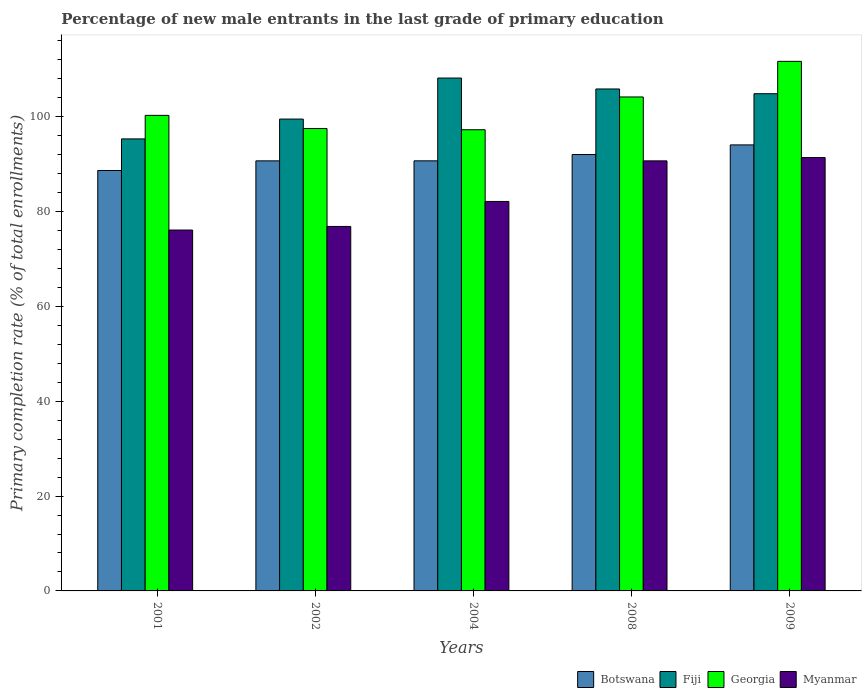How many bars are there on the 3rd tick from the left?
Your response must be concise. 4. How many bars are there on the 4th tick from the right?
Your answer should be very brief. 4. What is the label of the 3rd group of bars from the left?
Your response must be concise. 2004. In how many cases, is the number of bars for a given year not equal to the number of legend labels?
Ensure brevity in your answer.  0. What is the percentage of new male entrants in Botswana in 2008?
Offer a terse response. 92.02. Across all years, what is the maximum percentage of new male entrants in Botswana?
Provide a short and direct response. 94.05. Across all years, what is the minimum percentage of new male entrants in Fiji?
Provide a short and direct response. 95.32. What is the total percentage of new male entrants in Botswana in the graph?
Your answer should be compact. 456.12. What is the difference between the percentage of new male entrants in Myanmar in 2002 and that in 2008?
Keep it short and to the point. -13.83. What is the difference between the percentage of new male entrants in Georgia in 2008 and the percentage of new male entrants in Fiji in 2004?
Make the answer very short. -3.99. What is the average percentage of new male entrants in Botswana per year?
Offer a very short reply. 91.22. In the year 2001, what is the difference between the percentage of new male entrants in Georgia and percentage of new male entrants in Fiji?
Give a very brief answer. 4.96. What is the ratio of the percentage of new male entrants in Myanmar in 2004 to that in 2009?
Ensure brevity in your answer.  0.9. Is the difference between the percentage of new male entrants in Georgia in 2004 and 2009 greater than the difference between the percentage of new male entrants in Fiji in 2004 and 2009?
Your response must be concise. No. What is the difference between the highest and the second highest percentage of new male entrants in Fiji?
Offer a terse response. 2.3. What is the difference between the highest and the lowest percentage of new male entrants in Myanmar?
Keep it short and to the point. 15.28. What does the 2nd bar from the left in 2002 represents?
Provide a succinct answer. Fiji. What does the 1st bar from the right in 2002 represents?
Your answer should be compact. Myanmar. Is it the case that in every year, the sum of the percentage of new male entrants in Fiji and percentage of new male entrants in Myanmar is greater than the percentage of new male entrants in Georgia?
Offer a very short reply. Yes. How many bars are there?
Your response must be concise. 20. What is the difference between two consecutive major ticks on the Y-axis?
Your answer should be very brief. 20. Are the values on the major ticks of Y-axis written in scientific E-notation?
Provide a short and direct response. No. How many legend labels are there?
Ensure brevity in your answer.  4. What is the title of the graph?
Your response must be concise. Percentage of new male entrants in the last grade of primary education. What is the label or title of the X-axis?
Offer a very short reply. Years. What is the label or title of the Y-axis?
Keep it short and to the point. Primary completion rate (% of total enrollments). What is the Primary completion rate (% of total enrollments) of Botswana in 2001?
Your answer should be compact. 88.66. What is the Primary completion rate (% of total enrollments) of Fiji in 2001?
Make the answer very short. 95.32. What is the Primary completion rate (% of total enrollments) in Georgia in 2001?
Offer a terse response. 100.28. What is the Primary completion rate (% of total enrollments) of Myanmar in 2001?
Offer a very short reply. 76.1. What is the Primary completion rate (% of total enrollments) of Botswana in 2002?
Make the answer very short. 90.69. What is the Primary completion rate (% of total enrollments) in Fiji in 2002?
Provide a short and direct response. 99.5. What is the Primary completion rate (% of total enrollments) of Georgia in 2002?
Your answer should be very brief. 97.51. What is the Primary completion rate (% of total enrollments) of Myanmar in 2002?
Provide a short and direct response. 76.86. What is the Primary completion rate (% of total enrollments) in Botswana in 2004?
Offer a very short reply. 90.7. What is the Primary completion rate (% of total enrollments) in Fiji in 2004?
Your answer should be compact. 108.15. What is the Primary completion rate (% of total enrollments) in Georgia in 2004?
Provide a succinct answer. 97.25. What is the Primary completion rate (% of total enrollments) in Myanmar in 2004?
Your response must be concise. 82.13. What is the Primary completion rate (% of total enrollments) in Botswana in 2008?
Your answer should be compact. 92.02. What is the Primary completion rate (% of total enrollments) of Fiji in 2008?
Provide a succinct answer. 105.85. What is the Primary completion rate (% of total enrollments) in Georgia in 2008?
Give a very brief answer. 104.16. What is the Primary completion rate (% of total enrollments) in Myanmar in 2008?
Keep it short and to the point. 90.69. What is the Primary completion rate (% of total enrollments) in Botswana in 2009?
Keep it short and to the point. 94.05. What is the Primary completion rate (% of total enrollments) of Fiji in 2009?
Provide a short and direct response. 104.85. What is the Primary completion rate (% of total enrollments) in Georgia in 2009?
Provide a succinct answer. 111.67. What is the Primary completion rate (% of total enrollments) in Myanmar in 2009?
Make the answer very short. 91.38. Across all years, what is the maximum Primary completion rate (% of total enrollments) of Botswana?
Provide a succinct answer. 94.05. Across all years, what is the maximum Primary completion rate (% of total enrollments) in Fiji?
Give a very brief answer. 108.15. Across all years, what is the maximum Primary completion rate (% of total enrollments) of Georgia?
Your answer should be very brief. 111.67. Across all years, what is the maximum Primary completion rate (% of total enrollments) of Myanmar?
Make the answer very short. 91.38. Across all years, what is the minimum Primary completion rate (% of total enrollments) in Botswana?
Your answer should be compact. 88.66. Across all years, what is the minimum Primary completion rate (% of total enrollments) of Fiji?
Your answer should be compact. 95.32. Across all years, what is the minimum Primary completion rate (% of total enrollments) in Georgia?
Ensure brevity in your answer.  97.25. Across all years, what is the minimum Primary completion rate (% of total enrollments) of Myanmar?
Provide a succinct answer. 76.1. What is the total Primary completion rate (% of total enrollments) in Botswana in the graph?
Your answer should be compact. 456.12. What is the total Primary completion rate (% of total enrollments) of Fiji in the graph?
Provide a succinct answer. 513.68. What is the total Primary completion rate (% of total enrollments) in Georgia in the graph?
Offer a terse response. 510.88. What is the total Primary completion rate (% of total enrollments) of Myanmar in the graph?
Your answer should be compact. 417.16. What is the difference between the Primary completion rate (% of total enrollments) in Botswana in 2001 and that in 2002?
Keep it short and to the point. -2.03. What is the difference between the Primary completion rate (% of total enrollments) in Fiji in 2001 and that in 2002?
Your answer should be compact. -4.18. What is the difference between the Primary completion rate (% of total enrollments) of Georgia in 2001 and that in 2002?
Give a very brief answer. 2.77. What is the difference between the Primary completion rate (% of total enrollments) in Myanmar in 2001 and that in 2002?
Ensure brevity in your answer.  -0.76. What is the difference between the Primary completion rate (% of total enrollments) in Botswana in 2001 and that in 2004?
Give a very brief answer. -2.04. What is the difference between the Primary completion rate (% of total enrollments) in Fiji in 2001 and that in 2004?
Your answer should be very brief. -12.83. What is the difference between the Primary completion rate (% of total enrollments) in Georgia in 2001 and that in 2004?
Your answer should be compact. 3.03. What is the difference between the Primary completion rate (% of total enrollments) of Myanmar in 2001 and that in 2004?
Keep it short and to the point. -6.03. What is the difference between the Primary completion rate (% of total enrollments) of Botswana in 2001 and that in 2008?
Provide a short and direct response. -3.37. What is the difference between the Primary completion rate (% of total enrollments) of Fiji in 2001 and that in 2008?
Your response must be concise. -10.53. What is the difference between the Primary completion rate (% of total enrollments) of Georgia in 2001 and that in 2008?
Your answer should be compact. -3.88. What is the difference between the Primary completion rate (% of total enrollments) in Myanmar in 2001 and that in 2008?
Give a very brief answer. -14.58. What is the difference between the Primary completion rate (% of total enrollments) in Botswana in 2001 and that in 2009?
Your response must be concise. -5.4. What is the difference between the Primary completion rate (% of total enrollments) in Fiji in 2001 and that in 2009?
Your response must be concise. -9.53. What is the difference between the Primary completion rate (% of total enrollments) in Georgia in 2001 and that in 2009?
Offer a very short reply. -11.39. What is the difference between the Primary completion rate (% of total enrollments) of Myanmar in 2001 and that in 2009?
Give a very brief answer. -15.28. What is the difference between the Primary completion rate (% of total enrollments) of Botswana in 2002 and that in 2004?
Make the answer very short. -0.01. What is the difference between the Primary completion rate (% of total enrollments) of Fiji in 2002 and that in 2004?
Offer a very short reply. -8.65. What is the difference between the Primary completion rate (% of total enrollments) of Georgia in 2002 and that in 2004?
Make the answer very short. 0.25. What is the difference between the Primary completion rate (% of total enrollments) in Myanmar in 2002 and that in 2004?
Keep it short and to the point. -5.27. What is the difference between the Primary completion rate (% of total enrollments) of Botswana in 2002 and that in 2008?
Your answer should be very brief. -1.33. What is the difference between the Primary completion rate (% of total enrollments) of Fiji in 2002 and that in 2008?
Ensure brevity in your answer.  -6.35. What is the difference between the Primary completion rate (% of total enrollments) of Georgia in 2002 and that in 2008?
Offer a terse response. -6.66. What is the difference between the Primary completion rate (% of total enrollments) in Myanmar in 2002 and that in 2008?
Make the answer very short. -13.83. What is the difference between the Primary completion rate (% of total enrollments) in Botswana in 2002 and that in 2009?
Provide a succinct answer. -3.36. What is the difference between the Primary completion rate (% of total enrollments) in Fiji in 2002 and that in 2009?
Your answer should be compact. -5.35. What is the difference between the Primary completion rate (% of total enrollments) in Georgia in 2002 and that in 2009?
Provide a short and direct response. -14.17. What is the difference between the Primary completion rate (% of total enrollments) in Myanmar in 2002 and that in 2009?
Keep it short and to the point. -14.52. What is the difference between the Primary completion rate (% of total enrollments) of Botswana in 2004 and that in 2008?
Keep it short and to the point. -1.33. What is the difference between the Primary completion rate (% of total enrollments) in Fiji in 2004 and that in 2008?
Your response must be concise. 2.3. What is the difference between the Primary completion rate (% of total enrollments) in Georgia in 2004 and that in 2008?
Keep it short and to the point. -6.91. What is the difference between the Primary completion rate (% of total enrollments) of Myanmar in 2004 and that in 2008?
Keep it short and to the point. -8.56. What is the difference between the Primary completion rate (% of total enrollments) of Botswana in 2004 and that in 2009?
Make the answer very short. -3.36. What is the difference between the Primary completion rate (% of total enrollments) of Fiji in 2004 and that in 2009?
Make the answer very short. 3.3. What is the difference between the Primary completion rate (% of total enrollments) in Georgia in 2004 and that in 2009?
Your answer should be compact. -14.42. What is the difference between the Primary completion rate (% of total enrollments) of Myanmar in 2004 and that in 2009?
Provide a short and direct response. -9.25. What is the difference between the Primary completion rate (% of total enrollments) of Botswana in 2008 and that in 2009?
Your answer should be compact. -2.03. What is the difference between the Primary completion rate (% of total enrollments) in Georgia in 2008 and that in 2009?
Provide a succinct answer. -7.51. What is the difference between the Primary completion rate (% of total enrollments) of Myanmar in 2008 and that in 2009?
Provide a short and direct response. -0.7. What is the difference between the Primary completion rate (% of total enrollments) of Botswana in 2001 and the Primary completion rate (% of total enrollments) of Fiji in 2002?
Offer a very short reply. -10.84. What is the difference between the Primary completion rate (% of total enrollments) of Botswana in 2001 and the Primary completion rate (% of total enrollments) of Georgia in 2002?
Offer a very short reply. -8.85. What is the difference between the Primary completion rate (% of total enrollments) in Botswana in 2001 and the Primary completion rate (% of total enrollments) in Myanmar in 2002?
Ensure brevity in your answer.  11.8. What is the difference between the Primary completion rate (% of total enrollments) in Fiji in 2001 and the Primary completion rate (% of total enrollments) in Georgia in 2002?
Your answer should be compact. -2.19. What is the difference between the Primary completion rate (% of total enrollments) of Fiji in 2001 and the Primary completion rate (% of total enrollments) of Myanmar in 2002?
Provide a succinct answer. 18.46. What is the difference between the Primary completion rate (% of total enrollments) of Georgia in 2001 and the Primary completion rate (% of total enrollments) of Myanmar in 2002?
Your answer should be compact. 23.42. What is the difference between the Primary completion rate (% of total enrollments) in Botswana in 2001 and the Primary completion rate (% of total enrollments) in Fiji in 2004?
Your response must be concise. -19.5. What is the difference between the Primary completion rate (% of total enrollments) in Botswana in 2001 and the Primary completion rate (% of total enrollments) in Georgia in 2004?
Provide a succinct answer. -8.6. What is the difference between the Primary completion rate (% of total enrollments) of Botswana in 2001 and the Primary completion rate (% of total enrollments) of Myanmar in 2004?
Provide a short and direct response. 6.53. What is the difference between the Primary completion rate (% of total enrollments) in Fiji in 2001 and the Primary completion rate (% of total enrollments) in Georgia in 2004?
Provide a short and direct response. -1.93. What is the difference between the Primary completion rate (% of total enrollments) in Fiji in 2001 and the Primary completion rate (% of total enrollments) in Myanmar in 2004?
Your answer should be compact. 13.19. What is the difference between the Primary completion rate (% of total enrollments) in Georgia in 2001 and the Primary completion rate (% of total enrollments) in Myanmar in 2004?
Your answer should be compact. 18.15. What is the difference between the Primary completion rate (% of total enrollments) in Botswana in 2001 and the Primary completion rate (% of total enrollments) in Fiji in 2008?
Offer a very short reply. -17.19. What is the difference between the Primary completion rate (% of total enrollments) in Botswana in 2001 and the Primary completion rate (% of total enrollments) in Georgia in 2008?
Ensure brevity in your answer.  -15.51. What is the difference between the Primary completion rate (% of total enrollments) of Botswana in 2001 and the Primary completion rate (% of total enrollments) of Myanmar in 2008?
Make the answer very short. -2.03. What is the difference between the Primary completion rate (% of total enrollments) of Fiji in 2001 and the Primary completion rate (% of total enrollments) of Georgia in 2008?
Give a very brief answer. -8.84. What is the difference between the Primary completion rate (% of total enrollments) of Fiji in 2001 and the Primary completion rate (% of total enrollments) of Myanmar in 2008?
Your answer should be very brief. 4.63. What is the difference between the Primary completion rate (% of total enrollments) of Georgia in 2001 and the Primary completion rate (% of total enrollments) of Myanmar in 2008?
Offer a very short reply. 9.59. What is the difference between the Primary completion rate (% of total enrollments) of Botswana in 2001 and the Primary completion rate (% of total enrollments) of Fiji in 2009?
Your answer should be very brief. -16.19. What is the difference between the Primary completion rate (% of total enrollments) in Botswana in 2001 and the Primary completion rate (% of total enrollments) in Georgia in 2009?
Your answer should be compact. -23.02. What is the difference between the Primary completion rate (% of total enrollments) in Botswana in 2001 and the Primary completion rate (% of total enrollments) in Myanmar in 2009?
Ensure brevity in your answer.  -2.73. What is the difference between the Primary completion rate (% of total enrollments) of Fiji in 2001 and the Primary completion rate (% of total enrollments) of Georgia in 2009?
Offer a very short reply. -16.35. What is the difference between the Primary completion rate (% of total enrollments) in Fiji in 2001 and the Primary completion rate (% of total enrollments) in Myanmar in 2009?
Keep it short and to the point. 3.94. What is the difference between the Primary completion rate (% of total enrollments) in Georgia in 2001 and the Primary completion rate (% of total enrollments) in Myanmar in 2009?
Offer a very short reply. 8.9. What is the difference between the Primary completion rate (% of total enrollments) in Botswana in 2002 and the Primary completion rate (% of total enrollments) in Fiji in 2004?
Your answer should be compact. -17.46. What is the difference between the Primary completion rate (% of total enrollments) in Botswana in 2002 and the Primary completion rate (% of total enrollments) in Georgia in 2004?
Provide a succinct answer. -6.56. What is the difference between the Primary completion rate (% of total enrollments) in Botswana in 2002 and the Primary completion rate (% of total enrollments) in Myanmar in 2004?
Your answer should be compact. 8.56. What is the difference between the Primary completion rate (% of total enrollments) in Fiji in 2002 and the Primary completion rate (% of total enrollments) in Georgia in 2004?
Your answer should be compact. 2.25. What is the difference between the Primary completion rate (% of total enrollments) of Fiji in 2002 and the Primary completion rate (% of total enrollments) of Myanmar in 2004?
Offer a terse response. 17.37. What is the difference between the Primary completion rate (% of total enrollments) of Georgia in 2002 and the Primary completion rate (% of total enrollments) of Myanmar in 2004?
Your answer should be compact. 15.38. What is the difference between the Primary completion rate (% of total enrollments) of Botswana in 2002 and the Primary completion rate (% of total enrollments) of Fiji in 2008?
Keep it short and to the point. -15.16. What is the difference between the Primary completion rate (% of total enrollments) in Botswana in 2002 and the Primary completion rate (% of total enrollments) in Georgia in 2008?
Make the answer very short. -13.47. What is the difference between the Primary completion rate (% of total enrollments) of Botswana in 2002 and the Primary completion rate (% of total enrollments) of Myanmar in 2008?
Make the answer very short. 0. What is the difference between the Primary completion rate (% of total enrollments) of Fiji in 2002 and the Primary completion rate (% of total enrollments) of Georgia in 2008?
Your response must be concise. -4.66. What is the difference between the Primary completion rate (% of total enrollments) of Fiji in 2002 and the Primary completion rate (% of total enrollments) of Myanmar in 2008?
Offer a terse response. 8.81. What is the difference between the Primary completion rate (% of total enrollments) of Georgia in 2002 and the Primary completion rate (% of total enrollments) of Myanmar in 2008?
Offer a terse response. 6.82. What is the difference between the Primary completion rate (% of total enrollments) of Botswana in 2002 and the Primary completion rate (% of total enrollments) of Fiji in 2009?
Keep it short and to the point. -14.16. What is the difference between the Primary completion rate (% of total enrollments) of Botswana in 2002 and the Primary completion rate (% of total enrollments) of Georgia in 2009?
Your answer should be very brief. -20.98. What is the difference between the Primary completion rate (% of total enrollments) in Botswana in 2002 and the Primary completion rate (% of total enrollments) in Myanmar in 2009?
Ensure brevity in your answer.  -0.69. What is the difference between the Primary completion rate (% of total enrollments) of Fiji in 2002 and the Primary completion rate (% of total enrollments) of Georgia in 2009?
Ensure brevity in your answer.  -12.17. What is the difference between the Primary completion rate (% of total enrollments) in Fiji in 2002 and the Primary completion rate (% of total enrollments) in Myanmar in 2009?
Provide a succinct answer. 8.12. What is the difference between the Primary completion rate (% of total enrollments) in Georgia in 2002 and the Primary completion rate (% of total enrollments) in Myanmar in 2009?
Provide a succinct answer. 6.12. What is the difference between the Primary completion rate (% of total enrollments) in Botswana in 2004 and the Primary completion rate (% of total enrollments) in Fiji in 2008?
Provide a succinct answer. -15.15. What is the difference between the Primary completion rate (% of total enrollments) of Botswana in 2004 and the Primary completion rate (% of total enrollments) of Georgia in 2008?
Ensure brevity in your answer.  -13.47. What is the difference between the Primary completion rate (% of total enrollments) of Botswana in 2004 and the Primary completion rate (% of total enrollments) of Myanmar in 2008?
Your answer should be very brief. 0.01. What is the difference between the Primary completion rate (% of total enrollments) of Fiji in 2004 and the Primary completion rate (% of total enrollments) of Georgia in 2008?
Ensure brevity in your answer.  3.99. What is the difference between the Primary completion rate (% of total enrollments) of Fiji in 2004 and the Primary completion rate (% of total enrollments) of Myanmar in 2008?
Offer a very short reply. 17.47. What is the difference between the Primary completion rate (% of total enrollments) in Georgia in 2004 and the Primary completion rate (% of total enrollments) in Myanmar in 2008?
Provide a short and direct response. 6.57. What is the difference between the Primary completion rate (% of total enrollments) in Botswana in 2004 and the Primary completion rate (% of total enrollments) in Fiji in 2009?
Your response must be concise. -14.15. What is the difference between the Primary completion rate (% of total enrollments) of Botswana in 2004 and the Primary completion rate (% of total enrollments) of Georgia in 2009?
Provide a short and direct response. -20.98. What is the difference between the Primary completion rate (% of total enrollments) in Botswana in 2004 and the Primary completion rate (% of total enrollments) in Myanmar in 2009?
Provide a short and direct response. -0.69. What is the difference between the Primary completion rate (% of total enrollments) of Fiji in 2004 and the Primary completion rate (% of total enrollments) of Georgia in 2009?
Your answer should be very brief. -3.52. What is the difference between the Primary completion rate (% of total enrollments) in Fiji in 2004 and the Primary completion rate (% of total enrollments) in Myanmar in 2009?
Offer a terse response. 16.77. What is the difference between the Primary completion rate (% of total enrollments) in Georgia in 2004 and the Primary completion rate (% of total enrollments) in Myanmar in 2009?
Offer a terse response. 5.87. What is the difference between the Primary completion rate (% of total enrollments) in Botswana in 2008 and the Primary completion rate (% of total enrollments) in Fiji in 2009?
Offer a very short reply. -12.82. What is the difference between the Primary completion rate (% of total enrollments) in Botswana in 2008 and the Primary completion rate (% of total enrollments) in Georgia in 2009?
Your answer should be very brief. -19.65. What is the difference between the Primary completion rate (% of total enrollments) in Botswana in 2008 and the Primary completion rate (% of total enrollments) in Myanmar in 2009?
Provide a succinct answer. 0.64. What is the difference between the Primary completion rate (% of total enrollments) of Fiji in 2008 and the Primary completion rate (% of total enrollments) of Georgia in 2009?
Provide a short and direct response. -5.82. What is the difference between the Primary completion rate (% of total enrollments) in Fiji in 2008 and the Primary completion rate (% of total enrollments) in Myanmar in 2009?
Ensure brevity in your answer.  14.47. What is the difference between the Primary completion rate (% of total enrollments) in Georgia in 2008 and the Primary completion rate (% of total enrollments) in Myanmar in 2009?
Give a very brief answer. 12.78. What is the average Primary completion rate (% of total enrollments) of Botswana per year?
Your answer should be very brief. 91.22. What is the average Primary completion rate (% of total enrollments) in Fiji per year?
Keep it short and to the point. 102.73. What is the average Primary completion rate (% of total enrollments) of Georgia per year?
Make the answer very short. 102.18. What is the average Primary completion rate (% of total enrollments) in Myanmar per year?
Your response must be concise. 83.43. In the year 2001, what is the difference between the Primary completion rate (% of total enrollments) of Botswana and Primary completion rate (% of total enrollments) of Fiji?
Offer a terse response. -6.66. In the year 2001, what is the difference between the Primary completion rate (% of total enrollments) of Botswana and Primary completion rate (% of total enrollments) of Georgia?
Your answer should be compact. -11.62. In the year 2001, what is the difference between the Primary completion rate (% of total enrollments) in Botswana and Primary completion rate (% of total enrollments) in Myanmar?
Offer a very short reply. 12.55. In the year 2001, what is the difference between the Primary completion rate (% of total enrollments) in Fiji and Primary completion rate (% of total enrollments) in Georgia?
Your response must be concise. -4.96. In the year 2001, what is the difference between the Primary completion rate (% of total enrollments) of Fiji and Primary completion rate (% of total enrollments) of Myanmar?
Give a very brief answer. 19.22. In the year 2001, what is the difference between the Primary completion rate (% of total enrollments) in Georgia and Primary completion rate (% of total enrollments) in Myanmar?
Ensure brevity in your answer.  24.18. In the year 2002, what is the difference between the Primary completion rate (% of total enrollments) of Botswana and Primary completion rate (% of total enrollments) of Fiji?
Keep it short and to the point. -8.81. In the year 2002, what is the difference between the Primary completion rate (% of total enrollments) in Botswana and Primary completion rate (% of total enrollments) in Georgia?
Make the answer very short. -6.82. In the year 2002, what is the difference between the Primary completion rate (% of total enrollments) in Botswana and Primary completion rate (% of total enrollments) in Myanmar?
Keep it short and to the point. 13.83. In the year 2002, what is the difference between the Primary completion rate (% of total enrollments) in Fiji and Primary completion rate (% of total enrollments) in Georgia?
Your answer should be very brief. 2. In the year 2002, what is the difference between the Primary completion rate (% of total enrollments) of Fiji and Primary completion rate (% of total enrollments) of Myanmar?
Ensure brevity in your answer.  22.64. In the year 2002, what is the difference between the Primary completion rate (% of total enrollments) in Georgia and Primary completion rate (% of total enrollments) in Myanmar?
Your response must be concise. 20.65. In the year 2004, what is the difference between the Primary completion rate (% of total enrollments) of Botswana and Primary completion rate (% of total enrollments) of Fiji?
Provide a short and direct response. -17.46. In the year 2004, what is the difference between the Primary completion rate (% of total enrollments) in Botswana and Primary completion rate (% of total enrollments) in Georgia?
Offer a terse response. -6.56. In the year 2004, what is the difference between the Primary completion rate (% of total enrollments) in Botswana and Primary completion rate (% of total enrollments) in Myanmar?
Keep it short and to the point. 8.56. In the year 2004, what is the difference between the Primary completion rate (% of total enrollments) of Fiji and Primary completion rate (% of total enrollments) of Georgia?
Provide a succinct answer. 10.9. In the year 2004, what is the difference between the Primary completion rate (% of total enrollments) in Fiji and Primary completion rate (% of total enrollments) in Myanmar?
Provide a short and direct response. 26.02. In the year 2004, what is the difference between the Primary completion rate (% of total enrollments) in Georgia and Primary completion rate (% of total enrollments) in Myanmar?
Offer a terse response. 15.12. In the year 2008, what is the difference between the Primary completion rate (% of total enrollments) of Botswana and Primary completion rate (% of total enrollments) of Fiji?
Provide a short and direct response. -13.82. In the year 2008, what is the difference between the Primary completion rate (% of total enrollments) of Botswana and Primary completion rate (% of total enrollments) of Georgia?
Ensure brevity in your answer.  -12.14. In the year 2008, what is the difference between the Primary completion rate (% of total enrollments) in Botswana and Primary completion rate (% of total enrollments) in Myanmar?
Make the answer very short. 1.34. In the year 2008, what is the difference between the Primary completion rate (% of total enrollments) of Fiji and Primary completion rate (% of total enrollments) of Georgia?
Keep it short and to the point. 1.69. In the year 2008, what is the difference between the Primary completion rate (% of total enrollments) in Fiji and Primary completion rate (% of total enrollments) in Myanmar?
Ensure brevity in your answer.  15.16. In the year 2008, what is the difference between the Primary completion rate (% of total enrollments) in Georgia and Primary completion rate (% of total enrollments) in Myanmar?
Make the answer very short. 13.48. In the year 2009, what is the difference between the Primary completion rate (% of total enrollments) of Botswana and Primary completion rate (% of total enrollments) of Fiji?
Offer a terse response. -10.79. In the year 2009, what is the difference between the Primary completion rate (% of total enrollments) in Botswana and Primary completion rate (% of total enrollments) in Georgia?
Offer a terse response. -17.62. In the year 2009, what is the difference between the Primary completion rate (% of total enrollments) of Botswana and Primary completion rate (% of total enrollments) of Myanmar?
Your response must be concise. 2.67. In the year 2009, what is the difference between the Primary completion rate (% of total enrollments) of Fiji and Primary completion rate (% of total enrollments) of Georgia?
Your answer should be very brief. -6.82. In the year 2009, what is the difference between the Primary completion rate (% of total enrollments) of Fiji and Primary completion rate (% of total enrollments) of Myanmar?
Keep it short and to the point. 13.47. In the year 2009, what is the difference between the Primary completion rate (% of total enrollments) of Georgia and Primary completion rate (% of total enrollments) of Myanmar?
Make the answer very short. 20.29. What is the ratio of the Primary completion rate (% of total enrollments) in Botswana in 2001 to that in 2002?
Your response must be concise. 0.98. What is the ratio of the Primary completion rate (% of total enrollments) of Fiji in 2001 to that in 2002?
Give a very brief answer. 0.96. What is the ratio of the Primary completion rate (% of total enrollments) in Georgia in 2001 to that in 2002?
Provide a succinct answer. 1.03. What is the ratio of the Primary completion rate (% of total enrollments) of Botswana in 2001 to that in 2004?
Provide a succinct answer. 0.98. What is the ratio of the Primary completion rate (% of total enrollments) in Fiji in 2001 to that in 2004?
Your answer should be very brief. 0.88. What is the ratio of the Primary completion rate (% of total enrollments) in Georgia in 2001 to that in 2004?
Your response must be concise. 1.03. What is the ratio of the Primary completion rate (% of total enrollments) in Myanmar in 2001 to that in 2004?
Your response must be concise. 0.93. What is the ratio of the Primary completion rate (% of total enrollments) in Botswana in 2001 to that in 2008?
Your response must be concise. 0.96. What is the ratio of the Primary completion rate (% of total enrollments) of Fiji in 2001 to that in 2008?
Your answer should be compact. 0.9. What is the ratio of the Primary completion rate (% of total enrollments) in Georgia in 2001 to that in 2008?
Offer a terse response. 0.96. What is the ratio of the Primary completion rate (% of total enrollments) of Myanmar in 2001 to that in 2008?
Offer a terse response. 0.84. What is the ratio of the Primary completion rate (% of total enrollments) in Botswana in 2001 to that in 2009?
Provide a short and direct response. 0.94. What is the ratio of the Primary completion rate (% of total enrollments) of Fiji in 2001 to that in 2009?
Provide a succinct answer. 0.91. What is the ratio of the Primary completion rate (% of total enrollments) in Georgia in 2001 to that in 2009?
Provide a succinct answer. 0.9. What is the ratio of the Primary completion rate (% of total enrollments) in Myanmar in 2001 to that in 2009?
Your response must be concise. 0.83. What is the ratio of the Primary completion rate (% of total enrollments) of Georgia in 2002 to that in 2004?
Offer a very short reply. 1. What is the ratio of the Primary completion rate (% of total enrollments) in Myanmar in 2002 to that in 2004?
Make the answer very short. 0.94. What is the ratio of the Primary completion rate (% of total enrollments) of Botswana in 2002 to that in 2008?
Make the answer very short. 0.99. What is the ratio of the Primary completion rate (% of total enrollments) in Fiji in 2002 to that in 2008?
Your response must be concise. 0.94. What is the ratio of the Primary completion rate (% of total enrollments) of Georgia in 2002 to that in 2008?
Offer a terse response. 0.94. What is the ratio of the Primary completion rate (% of total enrollments) of Myanmar in 2002 to that in 2008?
Make the answer very short. 0.85. What is the ratio of the Primary completion rate (% of total enrollments) of Botswana in 2002 to that in 2009?
Give a very brief answer. 0.96. What is the ratio of the Primary completion rate (% of total enrollments) in Fiji in 2002 to that in 2009?
Give a very brief answer. 0.95. What is the ratio of the Primary completion rate (% of total enrollments) in Georgia in 2002 to that in 2009?
Your response must be concise. 0.87. What is the ratio of the Primary completion rate (% of total enrollments) in Myanmar in 2002 to that in 2009?
Ensure brevity in your answer.  0.84. What is the ratio of the Primary completion rate (% of total enrollments) of Botswana in 2004 to that in 2008?
Make the answer very short. 0.99. What is the ratio of the Primary completion rate (% of total enrollments) of Fiji in 2004 to that in 2008?
Give a very brief answer. 1.02. What is the ratio of the Primary completion rate (% of total enrollments) of Georgia in 2004 to that in 2008?
Give a very brief answer. 0.93. What is the ratio of the Primary completion rate (% of total enrollments) in Myanmar in 2004 to that in 2008?
Keep it short and to the point. 0.91. What is the ratio of the Primary completion rate (% of total enrollments) of Botswana in 2004 to that in 2009?
Provide a succinct answer. 0.96. What is the ratio of the Primary completion rate (% of total enrollments) of Fiji in 2004 to that in 2009?
Offer a terse response. 1.03. What is the ratio of the Primary completion rate (% of total enrollments) of Georgia in 2004 to that in 2009?
Ensure brevity in your answer.  0.87. What is the ratio of the Primary completion rate (% of total enrollments) in Myanmar in 2004 to that in 2009?
Offer a terse response. 0.9. What is the ratio of the Primary completion rate (% of total enrollments) of Botswana in 2008 to that in 2009?
Keep it short and to the point. 0.98. What is the ratio of the Primary completion rate (% of total enrollments) of Fiji in 2008 to that in 2009?
Give a very brief answer. 1.01. What is the ratio of the Primary completion rate (% of total enrollments) in Georgia in 2008 to that in 2009?
Give a very brief answer. 0.93. What is the difference between the highest and the second highest Primary completion rate (% of total enrollments) in Botswana?
Offer a terse response. 2.03. What is the difference between the highest and the second highest Primary completion rate (% of total enrollments) in Fiji?
Provide a short and direct response. 2.3. What is the difference between the highest and the second highest Primary completion rate (% of total enrollments) of Georgia?
Provide a succinct answer. 7.51. What is the difference between the highest and the second highest Primary completion rate (% of total enrollments) in Myanmar?
Offer a terse response. 0.7. What is the difference between the highest and the lowest Primary completion rate (% of total enrollments) in Botswana?
Keep it short and to the point. 5.4. What is the difference between the highest and the lowest Primary completion rate (% of total enrollments) in Fiji?
Make the answer very short. 12.83. What is the difference between the highest and the lowest Primary completion rate (% of total enrollments) in Georgia?
Your answer should be very brief. 14.42. What is the difference between the highest and the lowest Primary completion rate (% of total enrollments) in Myanmar?
Offer a very short reply. 15.28. 